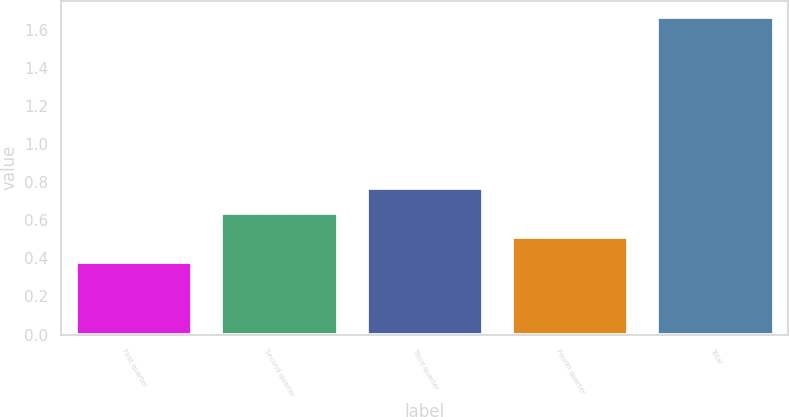Convert chart. <chart><loc_0><loc_0><loc_500><loc_500><bar_chart><fcel>First quarter<fcel>Second quarter<fcel>Third quarter<fcel>Fourth quarter<fcel>Total<nl><fcel>0.38<fcel>0.64<fcel>0.77<fcel>0.51<fcel>1.67<nl></chart> 